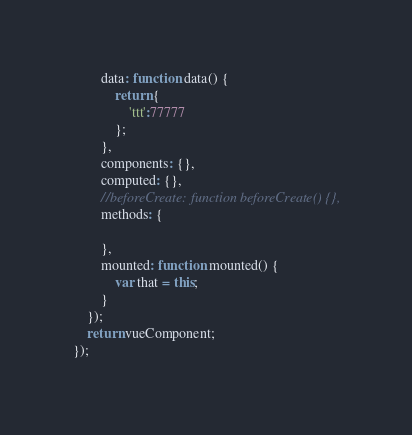<code> <loc_0><loc_0><loc_500><loc_500><_JavaScript_>        data: function data() {
            return {
                'ttt':77777
            };
        },
        components: {},
        computed: {},
        //beforeCreate: function beforeCreate() {},
        methods: {
        	
        },
        mounted: function mounted() {
            var that = this;
        }
    });
    return vueComponent;
});</code> 